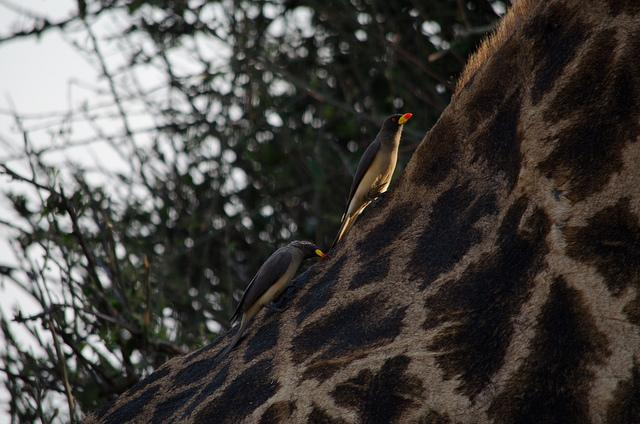Where are the birds standing on?

Choices:
A) giraffe
B) carpet
C) tree
D) blanket giraffe 